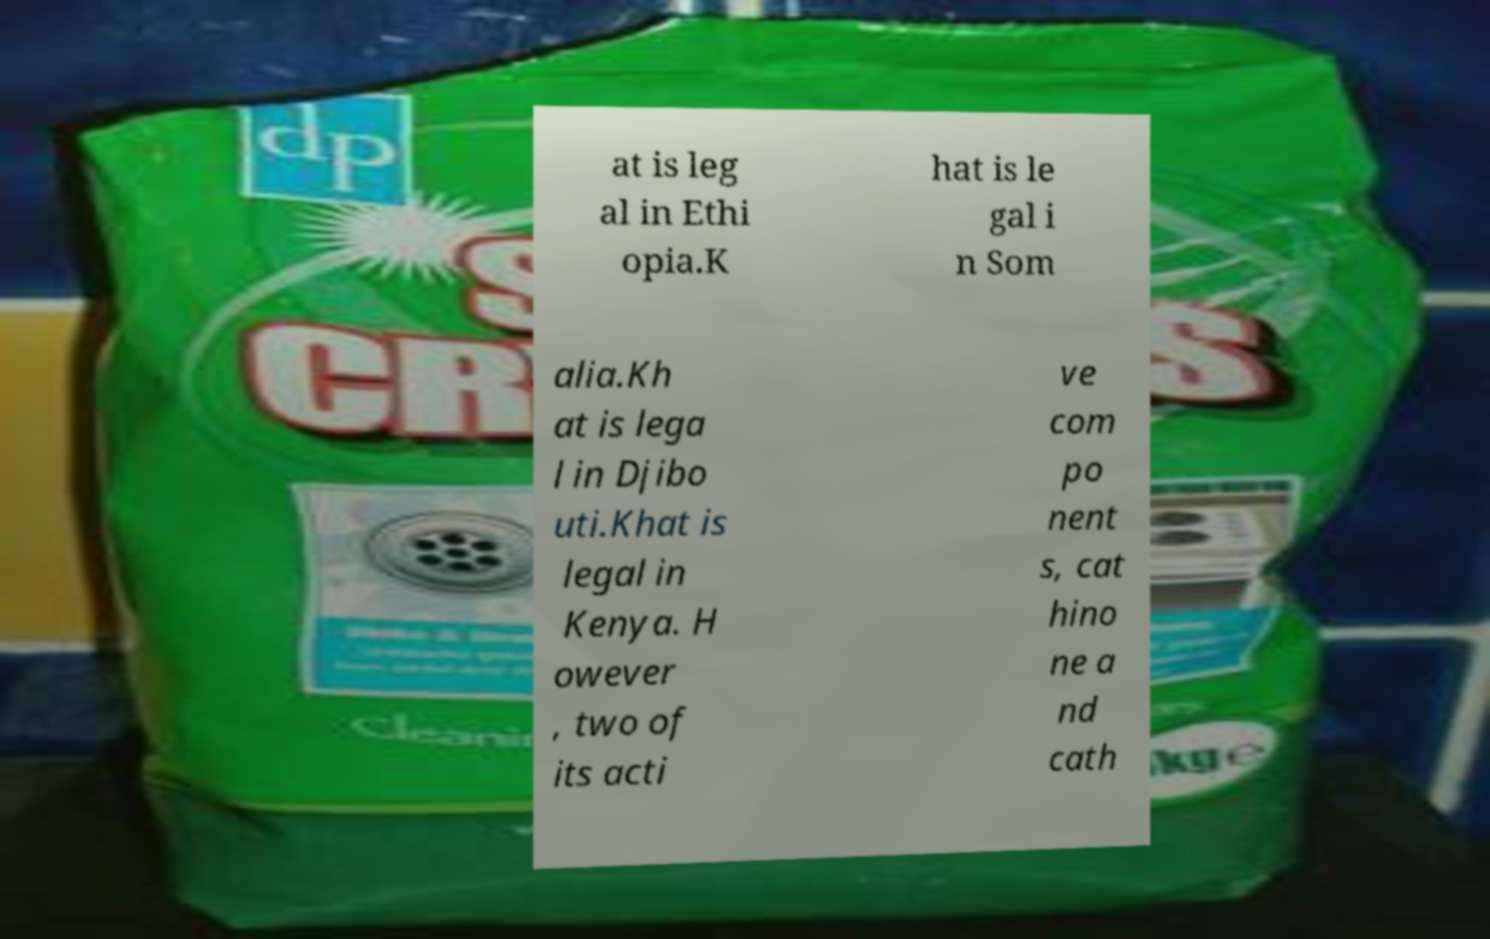I need the written content from this picture converted into text. Can you do that? at is leg al in Ethi opia.K hat is le gal i n Som alia.Kh at is lega l in Djibo uti.Khat is legal in Kenya. H owever , two of its acti ve com po nent s, cat hino ne a nd cath 